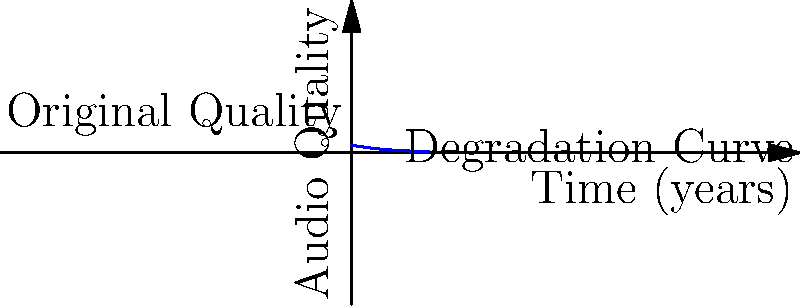As a music historian, you're analyzing the decay of audio quality in archival recordings. The graph shows the exponential decay of audio quality over time. If the initial quality is 100% and the decay rate is 20% per year, what percentage of the original quality remains after 5 years? To solve this problem, we need to use the exponential decay formula:

$$ Q(t) = Q_0 \cdot e^{-kt} $$

Where:
- $Q(t)$ is the quality at time $t$
- $Q_0$ is the initial quality (100% or 1.0)
- $k$ is the decay rate (20% or 0.2 per year)
- $t$ is the time in years (5 years)

Steps:
1. Input the values into the formula:
   $$ Q(5) = 1.0 \cdot e^{-0.2 \cdot 5} $$

2. Simplify the exponent:
   $$ Q(5) = 1.0 \cdot e^{-1} $$

3. Calculate the result:
   $$ Q(5) = 1.0 \cdot 0.3679 = 0.3679 $$

4. Convert to percentage:
   $$ 0.3679 \cdot 100\% = 36.79\% $$

Therefore, after 5 years, approximately 36.79% of the original audio quality remains.
Answer: 36.79% 